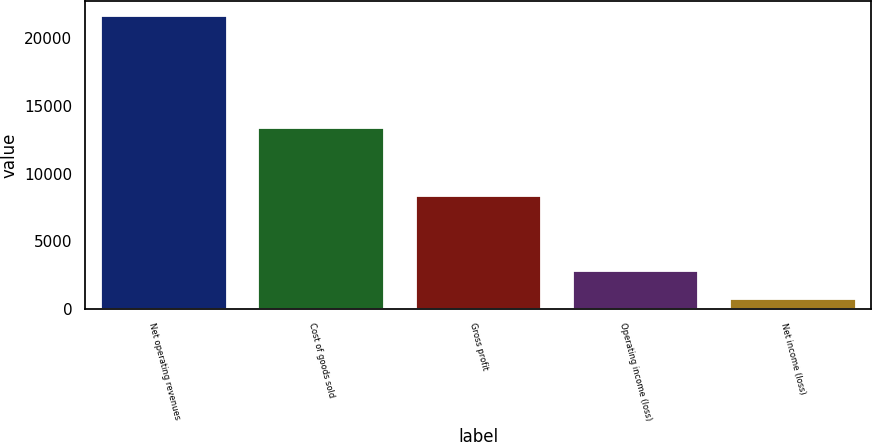Convert chart. <chart><loc_0><loc_0><loc_500><loc_500><bar_chart><fcel>Net operating revenues<fcel>Cost of goods sold<fcel>Gross profit<fcel>Operating income (loss)<fcel>Net income (loss)<nl><fcel>21645<fcel>13333<fcel>8312<fcel>2822.4<fcel>731<nl></chart> 